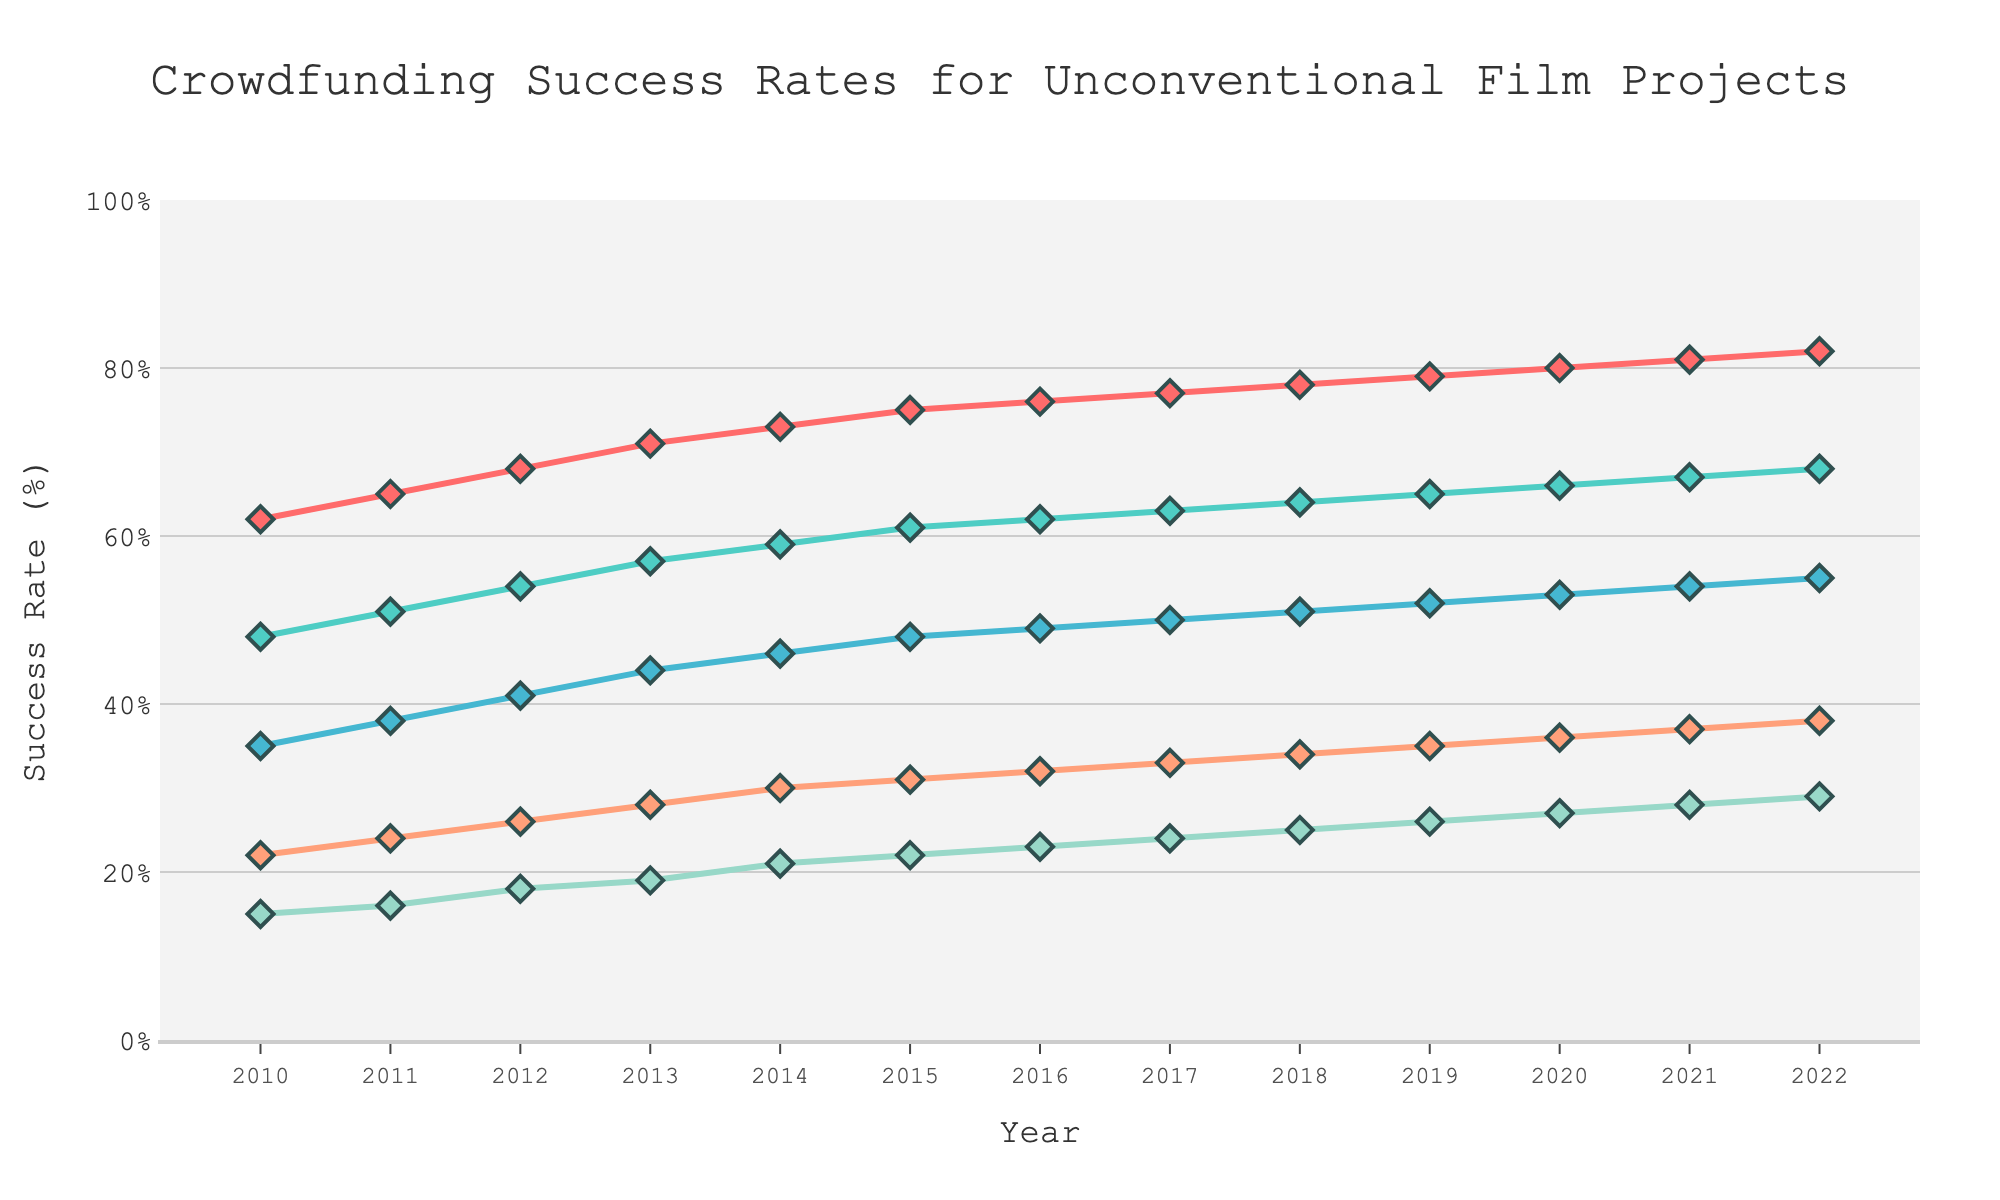What is the overall trend for success rates across all funding goal ranges from 2010 to 2022? The figure shows that success rates for all funding goal ranges have been consistently increasing from 2010 to 2022. Each line representing a different funding goal range trends upward over this period.
Answer: Increasing Which funding range had the highest success rate in 2022? Looking at the 2022 end of the figure, the line representing the "Under $10k" funding range is the highest on the y-axis, indicating the highest success rate.
Answer: Under $10k How does the success rate for the "10k-50k" range in 2016 compare to its success rate in 2022? The figure shows the success rate for the "10k-50k" range in 2016 is at 62%, while in 2022, it increased to 68%.
Answer: Higher in 2022 What is the difference in success rates between the "Under $10k" and "Over 250k" ranges in 2020? In 2020, the success rate for the "Under $10k" range is 80%, and for the "Over $250k" range, it is 27%. The difference is 80% - 27% = 53%.
Answer: 53% Which funding range has shown the most significant improvement in success rates from 2010 to 2022? By observing the slopes of the lines, the "Over $250k" range has shown the most significant relative improvement from 15% in 2010 to 29% in 2022, a 14% increase, though it remains the lowest absolute rate.
Answer: Over $250k How do the success rates in 2013 for the "10k-50k" and "50k-100k" funding ranges compare? In 2013, the success rate for "10k-50k" is 57%, and for "50k-100k", it is 44%. Therefore, the success rate for "10k-50k" is higher.
Answer: 10k-50k higher What is the average increase in success rate for the "Under $10k" range per year from 2010 to 2022? The success rate for "Under $10k" in 2010 is 62%, and in 2022 it is 82%. The total increase over 12 years is 82% - 62% = 20%, averaging 20% / 12 ≈ 1.67% per year.
Answer: 1.67% If we combined the success rates for "50k-100k" and "100k-250k" ranges in 2020, what would be the total? The success rate for "50k-100k" in 2020 is 53%, and for "100k-250k" it is 36%. Combined, it would be 53% + 36% = 89%.
Answer: 89% Compare the visual attributes of the "Under $10k" and "Over 250k" success rate lines. The "Under $10k" line is at the top in red, consistently the highest, with noticeable growth. The "Over $250k" line is at the bottom in mint color, showing significant but smaller growth visually.
Answer: "Under $10k" highest, "Over 250k" lowest In which year did the "100k-250k" range first reach a success rate above 30%? By observing the orange line representing "100k-250k," it first crosses the 30% success rate mark in 2014.
Answer: 2014 